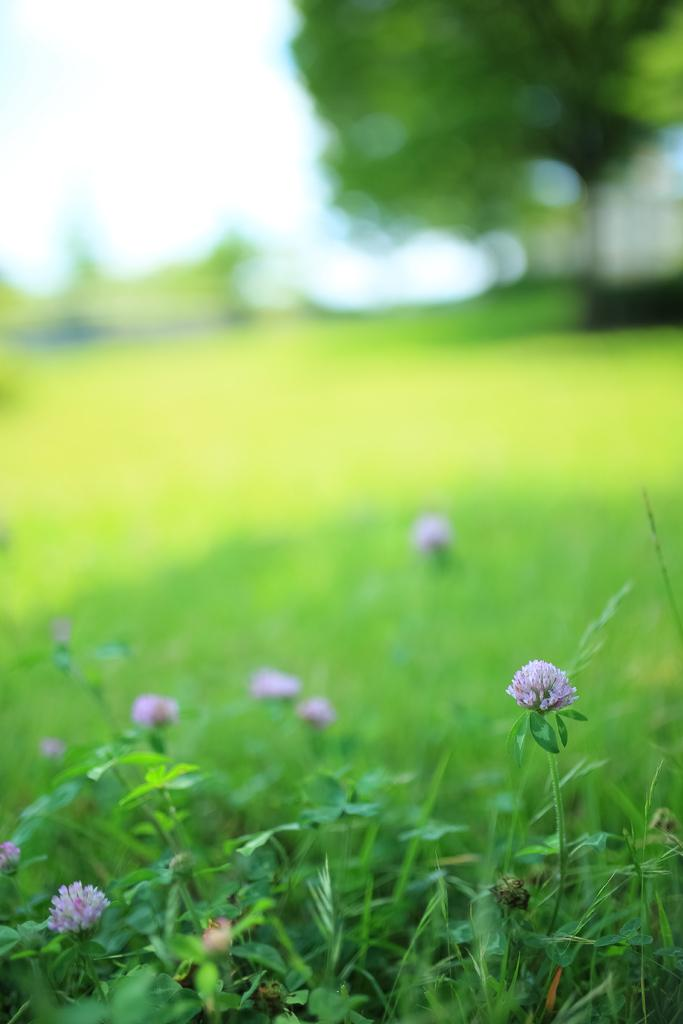What type of plants can be seen in the image? There are flowers in the image. What type of vegetation is present in the image besides flowers? There is grass in the image. Can you describe the background of the image? The background of the image is blurred. How many sails can be seen on the flowers in the image? There are no sails present on the flowers in the image; they are simply flowers. 